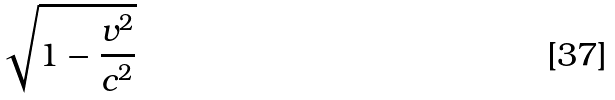Convert formula to latex. <formula><loc_0><loc_0><loc_500><loc_500>\sqrt { 1 - \frac { v ^ { 2 } } { c ^ { 2 } } }</formula> 